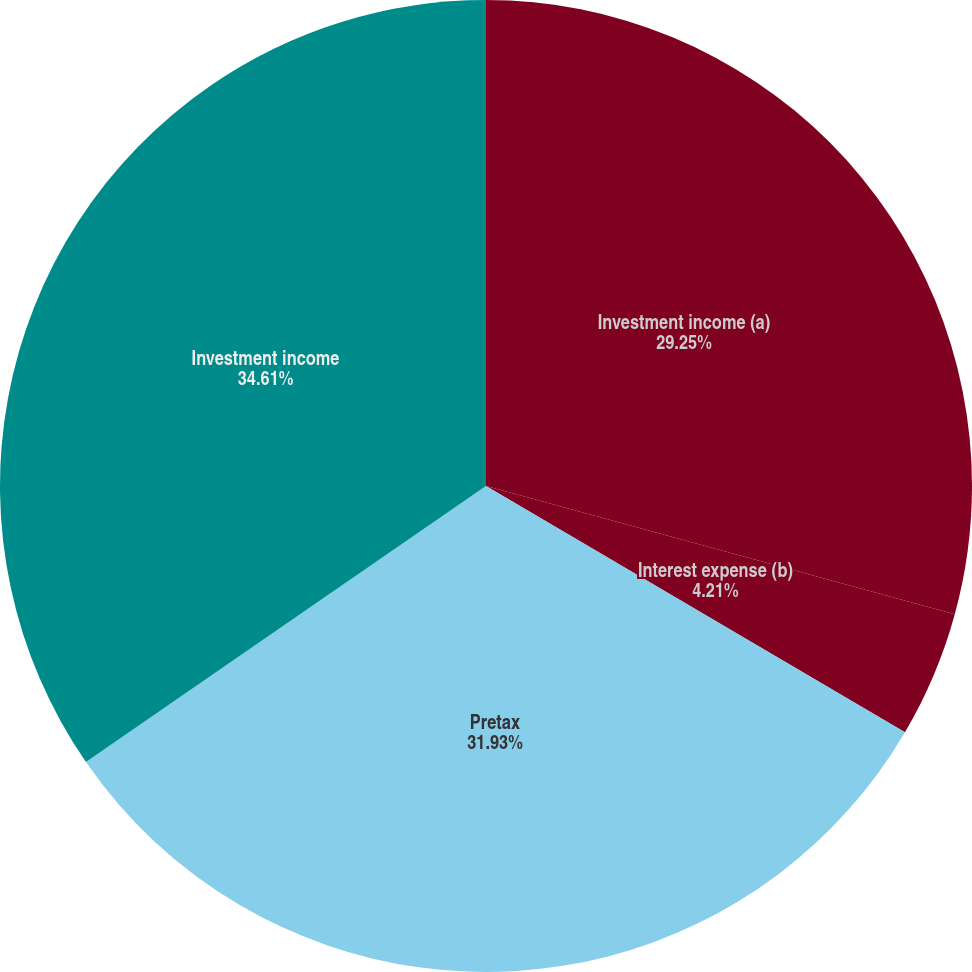Convert chart. <chart><loc_0><loc_0><loc_500><loc_500><pie_chart><fcel>Investment income (a)<fcel>Interest expense (b)<fcel>Pretax<fcel>Investment income<nl><fcel>29.25%<fcel>4.21%<fcel>31.93%<fcel>34.61%<nl></chart> 